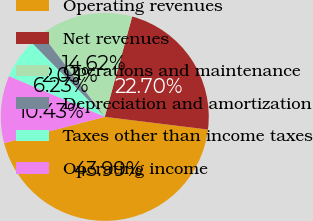Convert chart. <chart><loc_0><loc_0><loc_500><loc_500><pie_chart><fcel>Operating revenues<fcel>Net revenues<fcel>Operations and maintenance<fcel>Depreciation and amortization<fcel>Taxes other than income taxes<fcel>Operating income<nl><fcel>43.99%<fcel>22.7%<fcel>14.62%<fcel>2.03%<fcel>6.23%<fcel>10.43%<nl></chart> 